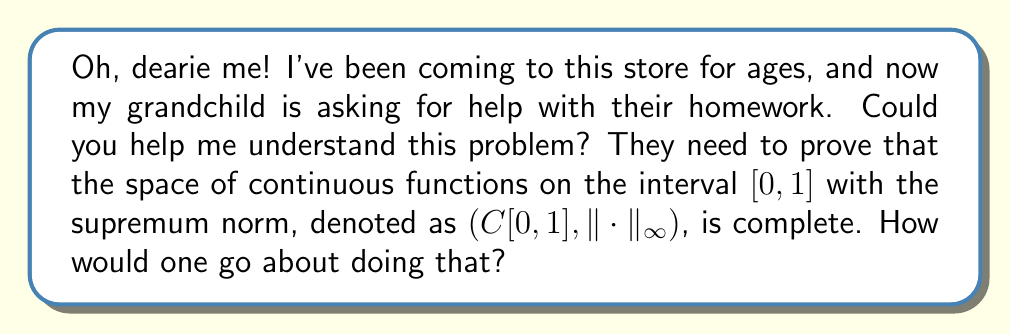Teach me how to tackle this problem. Certainly! Let's break this down step-by-step:

1) First, we need to understand what completeness means. A normed space is complete if every Cauchy sequence in the space converges to an element in the space.

2) Let's consider a Cauchy sequence of functions $\{f_n\}$ in $C[0,1]$. We need to show that this sequence converges to a function $f$ that is also in $C[0,1]$.

3) For any $\epsilon > 0$, there exists an $N$ such that for all $m,n > N$:

   $$\|f_m - f_n\|_{\infty} < \epsilon$$

4) This means that for any $x \in [0,1]$:

   $$|f_m(x) - f_n(x)| < \epsilon$$

5) For a fixed $x$, $\{f_n(x)\}$ is a Cauchy sequence in $\mathbb{R}$. Since $\mathbb{R}$ is complete, this sequence converges to some real number, which we'll call $f(x)$.

6) We've defined a function $f:[0,1] \to \mathbb{R}$. We need to show that $f$ is continuous and that $f_n$ converges to $f$ in the supremum norm.

7) To show continuity, let $x,y \in [0,1]$. Then:

   $$|f(x) - f(y)| \leq |f(x) - f_n(x)| + |f_n(x) - f_n(y)| + |f_n(y) - f(y)|$$

8) The first and third terms can be made arbitrarily small by choosing large $n$, and the middle term is small for $x$ close to $y$ because $f_n$ is continuous. This proves $f$ is continuous.

9) Finally, we need to show $\|f_n - f\|_{\infty} \to 0$. Given $\epsilon > 0$, choose $N$ such that $\|f_m - f_n\|_{\infty} < \epsilon/2$ for $m,n > N$. Then for any $x \in [0,1]$ and $n > N$:

   $$|f_n(x) - f(x)| = \lim_{m\to\infty} |f_n(x) - f_m(x)| \leq \epsilon/2$$

   This implies $\|f_n - f\|_{\infty} \leq \epsilon/2 < \epsilon$ for $n > N$.

Therefore, $f \in C[0,1]$ and $f_n \to f$ in the supremum norm, proving completeness.
Answer: The space $(C[0,1], \|\cdot\|_{\infty})$ is complete. 